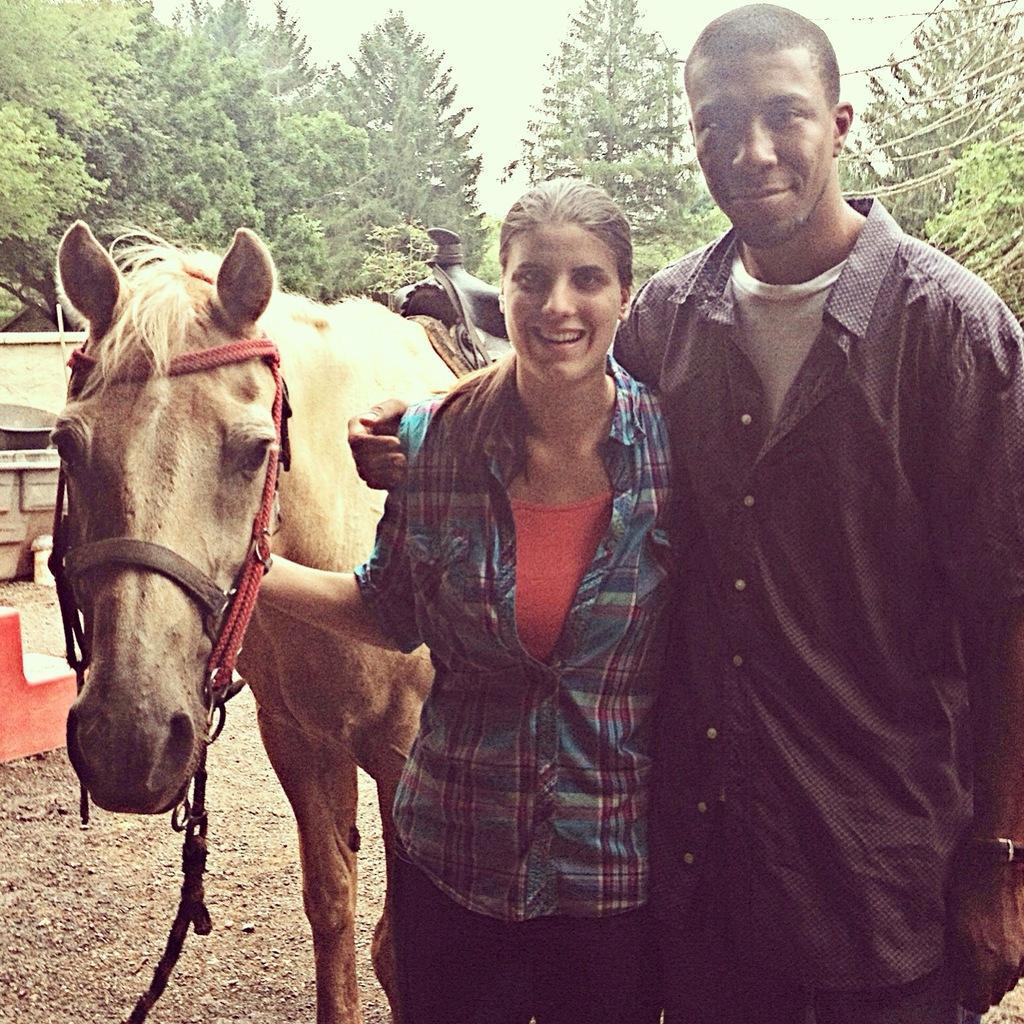Could you give a brief overview of what you see in this image? In front of the image there are two people having a smile on their faces. Beside them there is a horse. On the left side of the image there are some objects. In the background of the image there are trees. At the top of the image there is sky. 